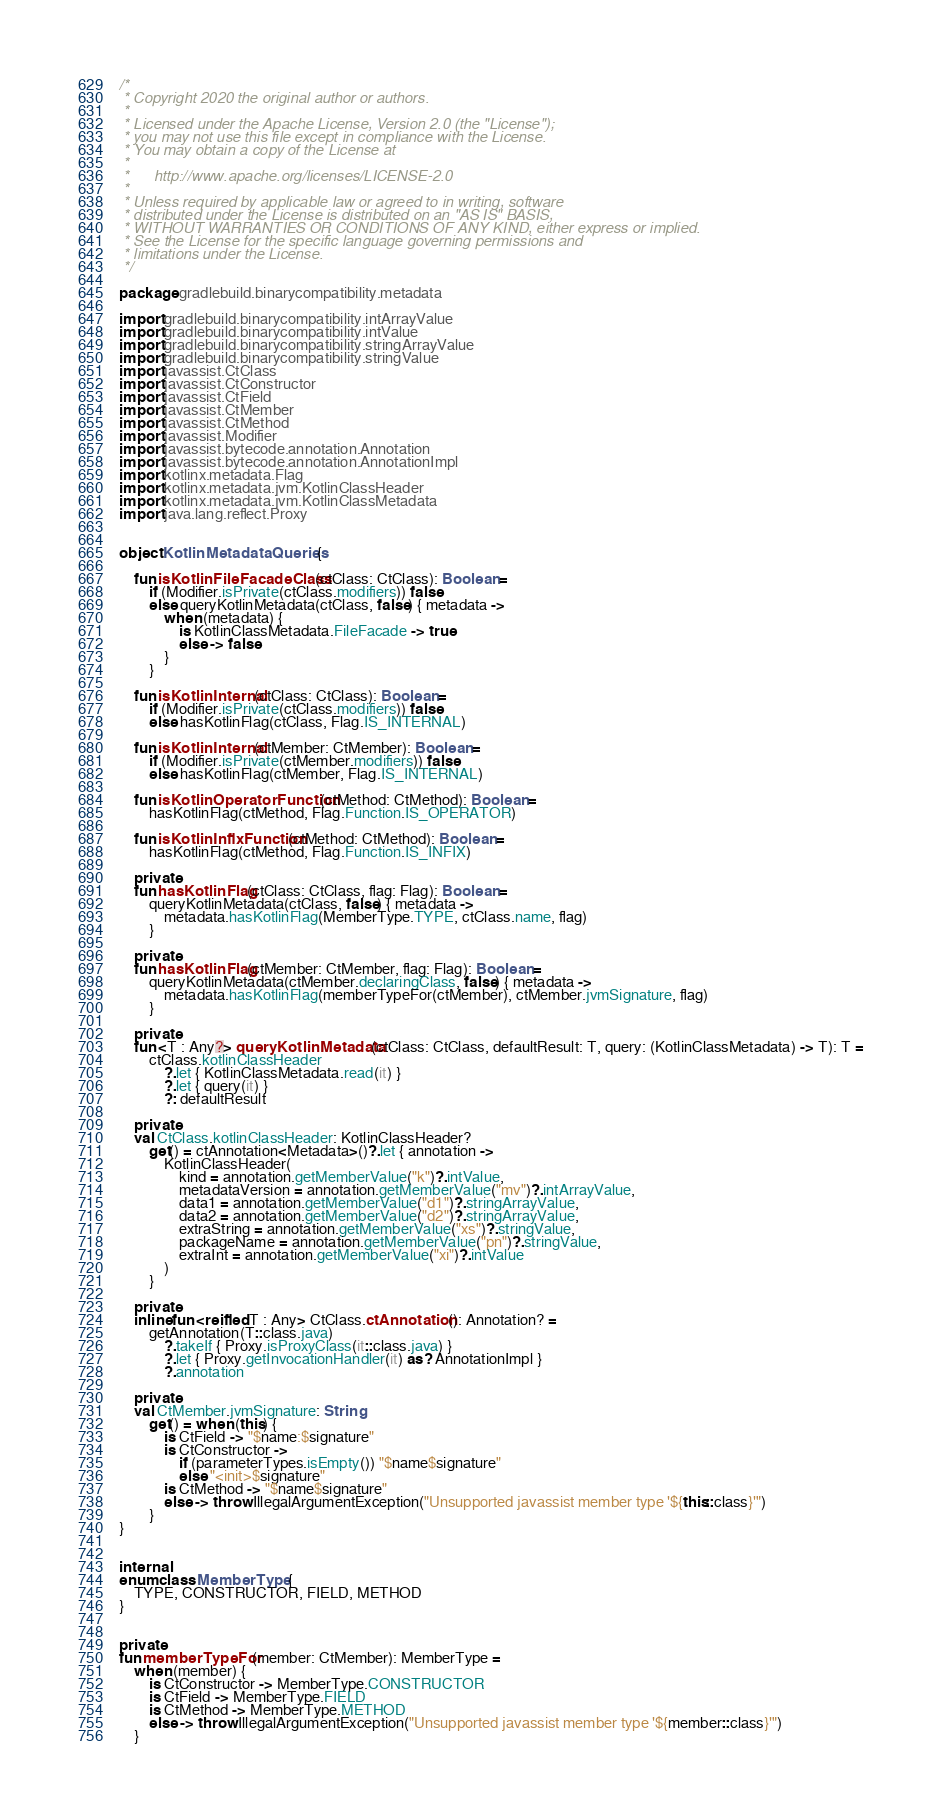Convert code to text. <code><loc_0><loc_0><loc_500><loc_500><_Kotlin_>/*
 * Copyright 2020 the original author or authors.
 *
 * Licensed under the Apache License, Version 2.0 (the "License");
 * you may not use this file except in compliance with the License.
 * You may obtain a copy of the License at
 *
 *      http://www.apache.org/licenses/LICENSE-2.0
 *
 * Unless required by applicable law or agreed to in writing, software
 * distributed under the License is distributed on an "AS IS" BASIS,
 * WITHOUT WARRANTIES OR CONDITIONS OF ANY KIND, either express or implied.
 * See the License for the specific language governing permissions and
 * limitations under the License.
 */

package gradlebuild.binarycompatibility.metadata

import gradlebuild.binarycompatibility.intArrayValue
import gradlebuild.binarycompatibility.intValue
import gradlebuild.binarycompatibility.stringArrayValue
import gradlebuild.binarycompatibility.stringValue
import javassist.CtClass
import javassist.CtConstructor
import javassist.CtField
import javassist.CtMember
import javassist.CtMethod
import javassist.Modifier
import javassist.bytecode.annotation.Annotation
import javassist.bytecode.annotation.AnnotationImpl
import kotlinx.metadata.Flag
import kotlinx.metadata.jvm.KotlinClassHeader
import kotlinx.metadata.jvm.KotlinClassMetadata
import java.lang.reflect.Proxy


object KotlinMetadataQueries {

    fun isKotlinFileFacadeClass(ctClass: CtClass): Boolean =
        if (Modifier.isPrivate(ctClass.modifiers)) false
        else queryKotlinMetadata(ctClass, false) { metadata ->
            when (metadata) {
                is KotlinClassMetadata.FileFacade -> true
                else -> false
            }
        }

    fun isKotlinInternal(ctClass: CtClass): Boolean =
        if (Modifier.isPrivate(ctClass.modifiers)) false
        else hasKotlinFlag(ctClass, Flag.IS_INTERNAL)

    fun isKotlinInternal(ctMember: CtMember): Boolean =
        if (Modifier.isPrivate(ctMember.modifiers)) false
        else hasKotlinFlag(ctMember, Flag.IS_INTERNAL)

    fun isKotlinOperatorFunction(ctMethod: CtMethod): Boolean =
        hasKotlinFlag(ctMethod, Flag.Function.IS_OPERATOR)

    fun isKotlinInfixFunction(ctMethod: CtMethod): Boolean =
        hasKotlinFlag(ctMethod, Flag.Function.IS_INFIX)

    private
    fun hasKotlinFlag(ctClass: CtClass, flag: Flag): Boolean =
        queryKotlinMetadata(ctClass, false) { metadata ->
            metadata.hasKotlinFlag(MemberType.TYPE, ctClass.name, flag)
        }

    private
    fun hasKotlinFlag(ctMember: CtMember, flag: Flag): Boolean =
        queryKotlinMetadata(ctMember.declaringClass, false) { metadata ->
            metadata.hasKotlinFlag(memberTypeFor(ctMember), ctMember.jvmSignature, flag)
        }

    private
    fun <T : Any?> queryKotlinMetadata(ctClass: CtClass, defaultResult: T, query: (KotlinClassMetadata) -> T): T =
        ctClass.kotlinClassHeader
            ?.let { KotlinClassMetadata.read(it) }
            ?.let { query(it) }
            ?: defaultResult

    private
    val CtClass.kotlinClassHeader: KotlinClassHeader?
        get() = ctAnnotation<Metadata>()?.let { annotation ->
            KotlinClassHeader(
                kind = annotation.getMemberValue("k")?.intValue,
                metadataVersion = annotation.getMemberValue("mv")?.intArrayValue,
                data1 = annotation.getMemberValue("d1")?.stringArrayValue,
                data2 = annotation.getMemberValue("d2")?.stringArrayValue,
                extraString = annotation.getMemberValue("xs")?.stringValue,
                packageName = annotation.getMemberValue("pn")?.stringValue,
                extraInt = annotation.getMemberValue("xi")?.intValue
            )
        }

    private
    inline fun <reified T : Any> CtClass.ctAnnotation(): Annotation? =
        getAnnotation(T::class.java)
            ?.takeIf { Proxy.isProxyClass(it::class.java) }
            ?.let { Proxy.getInvocationHandler(it) as? AnnotationImpl }
            ?.annotation

    private
    val CtMember.jvmSignature: String
        get() = when (this) {
            is CtField -> "$name:$signature"
            is CtConstructor ->
                if (parameterTypes.isEmpty()) "$name$signature"
                else "<init>$signature"
            is CtMethod -> "$name$signature"
            else -> throw IllegalArgumentException("Unsupported javassist member type '${this::class}'")
        }
}


internal
enum class MemberType {
    TYPE, CONSTRUCTOR, FIELD, METHOD
}


private
fun memberTypeFor(member: CtMember): MemberType =
    when (member) {
        is CtConstructor -> MemberType.CONSTRUCTOR
        is CtField -> MemberType.FIELD
        is CtMethod -> MemberType.METHOD
        else -> throw IllegalArgumentException("Unsupported javassist member type '${member::class}'")
    }
</code> 